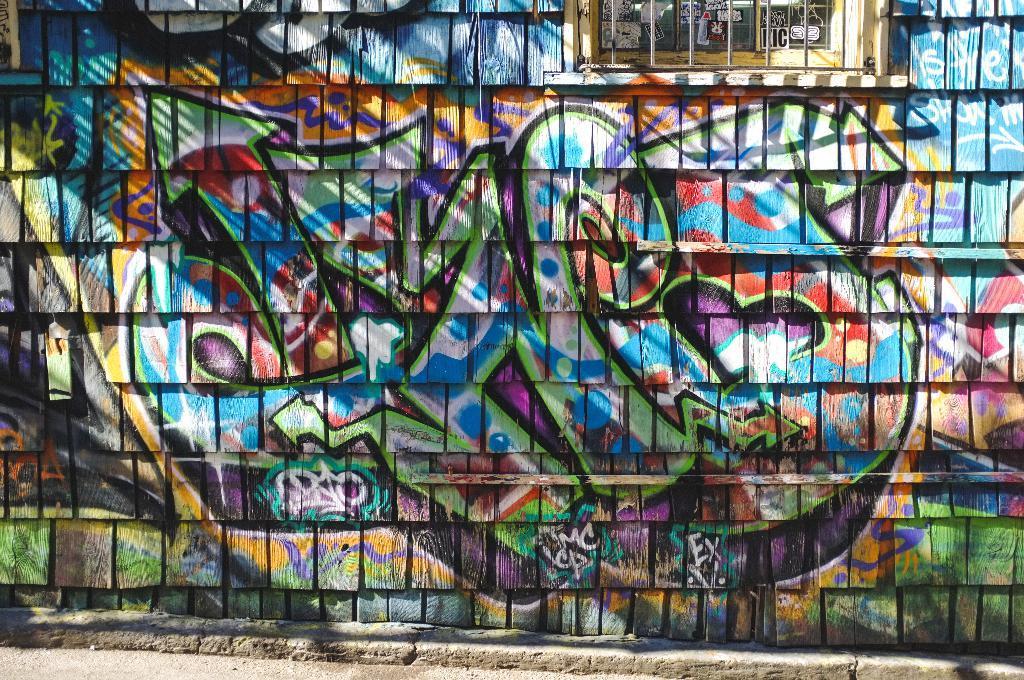Can you describe this image briefly? In the picture there is a wall and to the wall there is a window,on the wall there is a graffiti. 